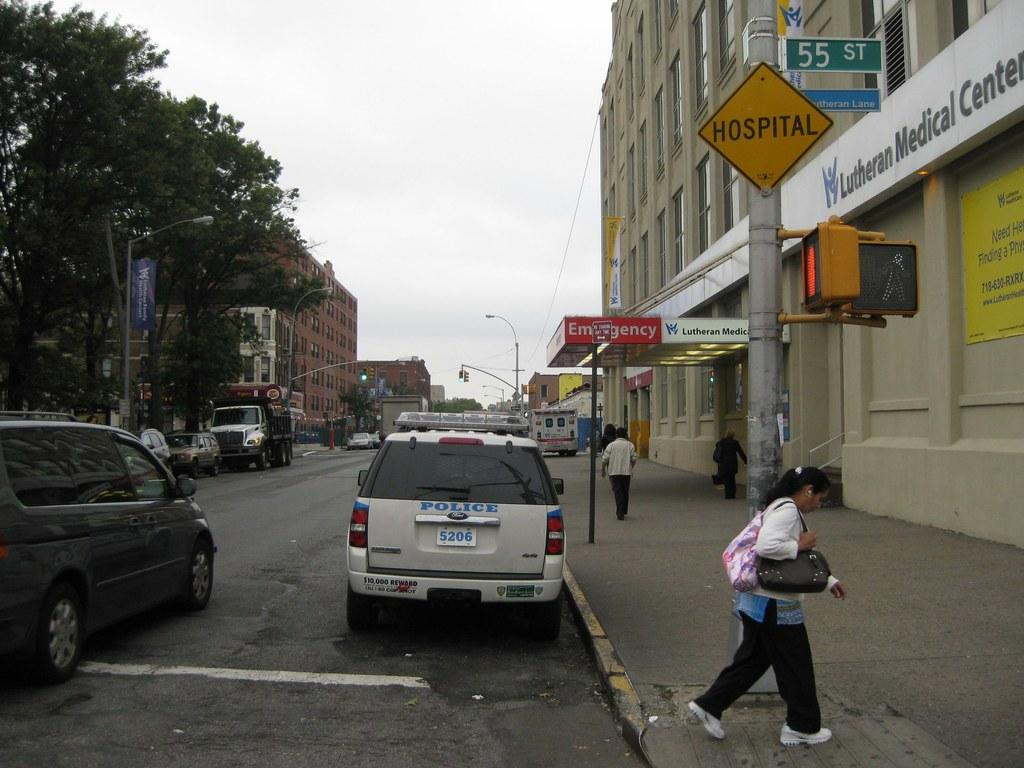<image>
Describe the image concisely. A woman has crossed the street and is walking past a yellow square sign that says HOSPITAL above her head. 